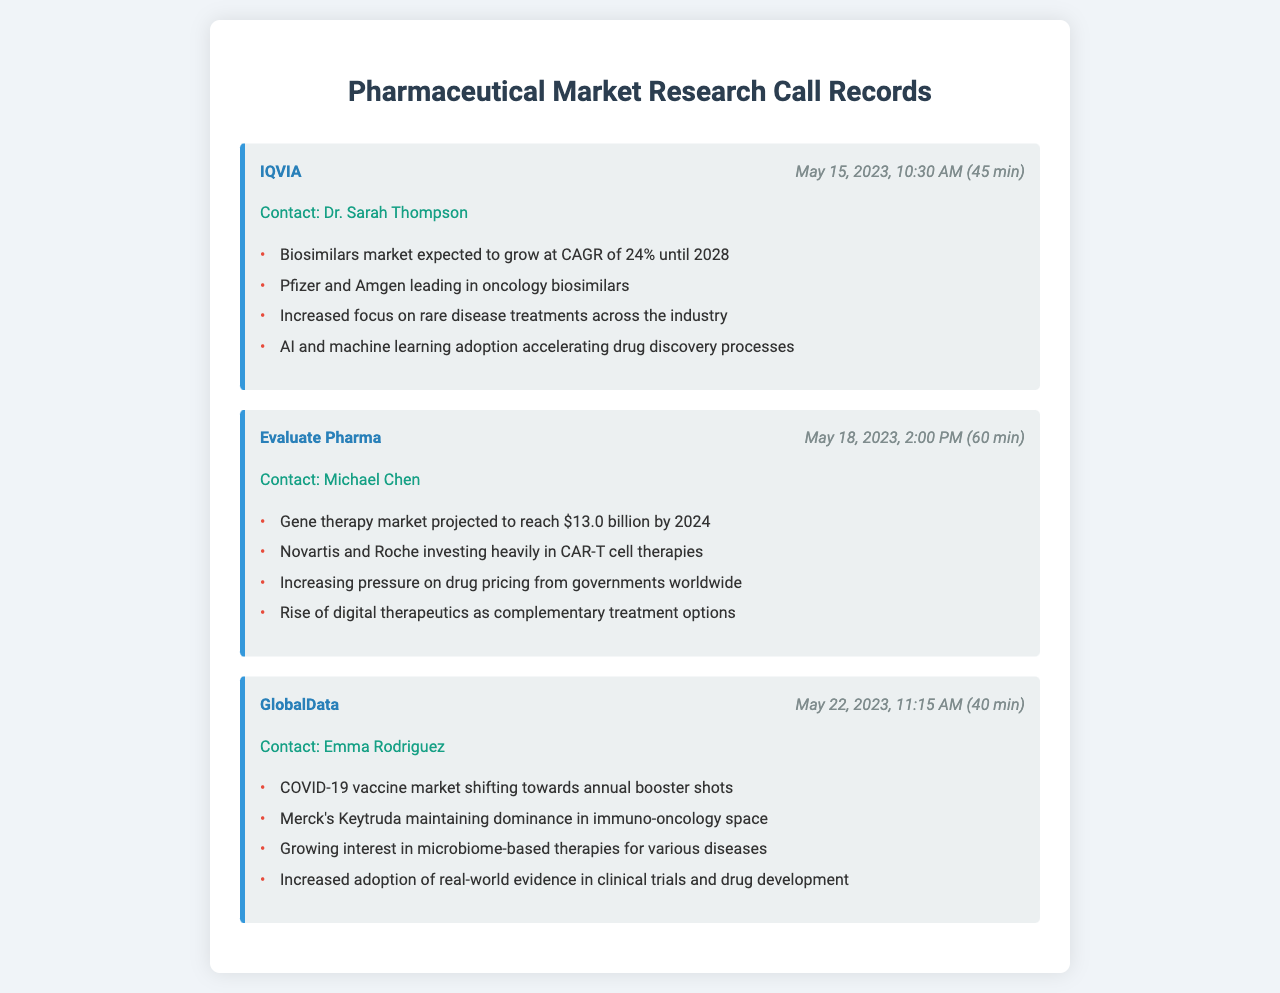What firm conducted the call on May 15, 2023? The firm that conducted the call on May 15, 2023, is mentioned in the call record.
Answer: IQVIA Who was the contact person for the call with Evaluate Pharma? The contact person for the call with Evaluate Pharma is given in the document under the respective firm's call record.
Answer: Michael Chen What is the projected growth rate for the biosimilars market? The growth rate for the biosimilars market is stated as a percentage in the document.
Answer: 24% Which company is mentioned as maintaining dominance in the immuno-oncology space? The document lists a specific company's dominance in the immuno-oncology market.
Answer: Merck How long did the call with GlobalData last? The duration of the call with GlobalData is indicated in the call record.
Answer: 40 minutes What market is projected to reach $13.0 billion by 2024? This market projection is explicitly stated in the call record under Evaluate Pharma.
Answer: Gene therapy Which companies are investing heavily in CAR-T cell therapies? The document points out two companies in its key points section.
Answer: Novartis and Roche What is a key trend mentioned in the call with IQVIA regarding drug discovery? The trend discussed is focused on technology adoption in drug discovery as noted in the key points.
Answer: AI and machine learning adoption What is the shifting focus of the COVID-19 vaccine market? The document indicates a specific shift in focus regarding COVID-19 vaccines.
Answer: Annual booster shots 